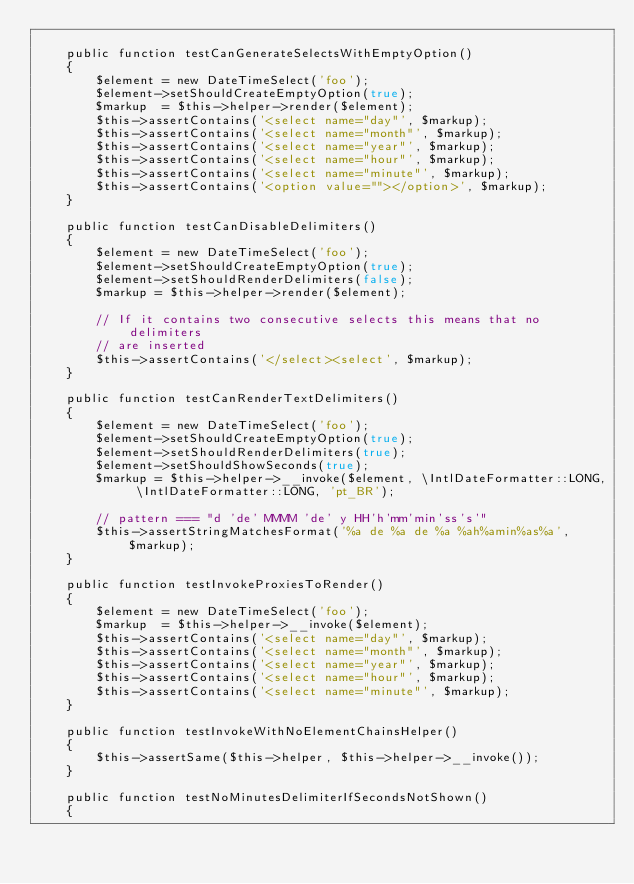<code> <loc_0><loc_0><loc_500><loc_500><_PHP_>
    public function testCanGenerateSelectsWithEmptyOption()
    {
        $element = new DateTimeSelect('foo');
        $element->setShouldCreateEmptyOption(true);
        $markup  = $this->helper->render($element);
        $this->assertContains('<select name="day"', $markup);
        $this->assertContains('<select name="month"', $markup);
        $this->assertContains('<select name="year"', $markup);
        $this->assertContains('<select name="hour"', $markup);
        $this->assertContains('<select name="minute"', $markup);
        $this->assertContains('<option value=""></option>', $markup);
    }

    public function testCanDisableDelimiters()
    {
        $element = new DateTimeSelect('foo');
        $element->setShouldCreateEmptyOption(true);
        $element->setShouldRenderDelimiters(false);
        $markup = $this->helper->render($element);

        // If it contains two consecutive selects this means that no delimiters
        // are inserted
        $this->assertContains('</select><select', $markup);
    }

    public function testCanRenderTextDelimiters()
    {
        $element = new DateTimeSelect('foo');
        $element->setShouldCreateEmptyOption(true);
        $element->setShouldRenderDelimiters(true);
        $element->setShouldShowSeconds(true);
        $markup = $this->helper->__invoke($element, \IntlDateFormatter::LONG, \IntlDateFormatter::LONG, 'pt_BR');

        // pattern === "d 'de' MMMM 'de' y HH'h'mm'min'ss's'"
        $this->assertStringMatchesFormat('%a de %a de %a %ah%amin%as%a', $markup);
    }

    public function testInvokeProxiesToRender()
    {
        $element = new DateTimeSelect('foo');
        $markup  = $this->helper->__invoke($element);
        $this->assertContains('<select name="day"', $markup);
        $this->assertContains('<select name="month"', $markup);
        $this->assertContains('<select name="year"', $markup);
        $this->assertContains('<select name="hour"', $markup);
        $this->assertContains('<select name="minute"', $markup);
    }

    public function testInvokeWithNoElementChainsHelper()
    {
        $this->assertSame($this->helper, $this->helper->__invoke());
    }

    public function testNoMinutesDelimiterIfSecondsNotShown()
    {</code> 